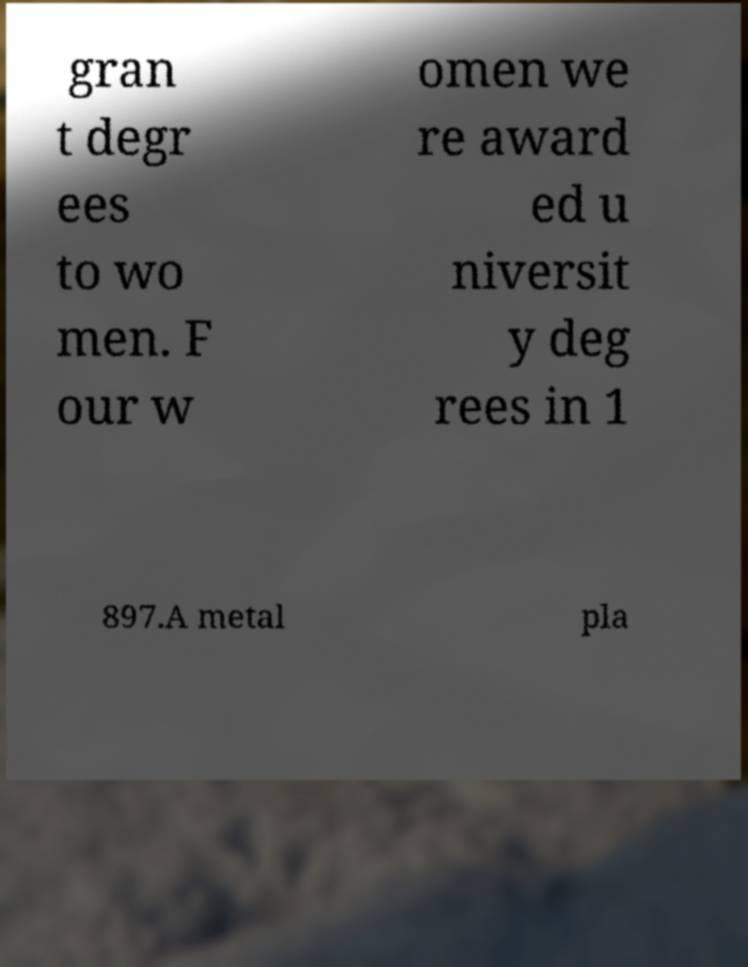I need the written content from this picture converted into text. Can you do that? gran t degr ees to wo men. F our w omen we re award ed u niversit y deg rees in 1 897.A metal pla 